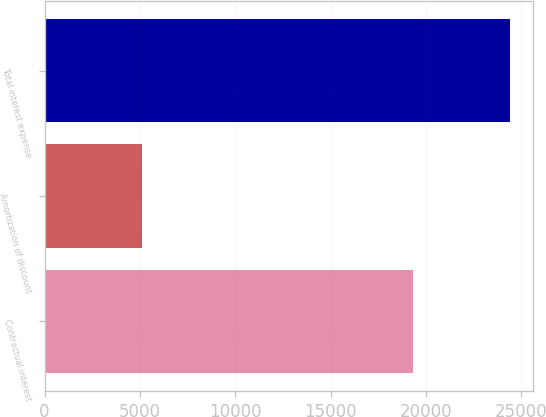Convert chart to OTSL. <chart><loc_0><loc_0><loc_500><loc_500><bar_chart><fcel>Contractual interest<fcel>Amortization of discount<fcel>Total interest expense<nl><fcel>19303<fcel>5103<fcel>24406<nl></chart> 